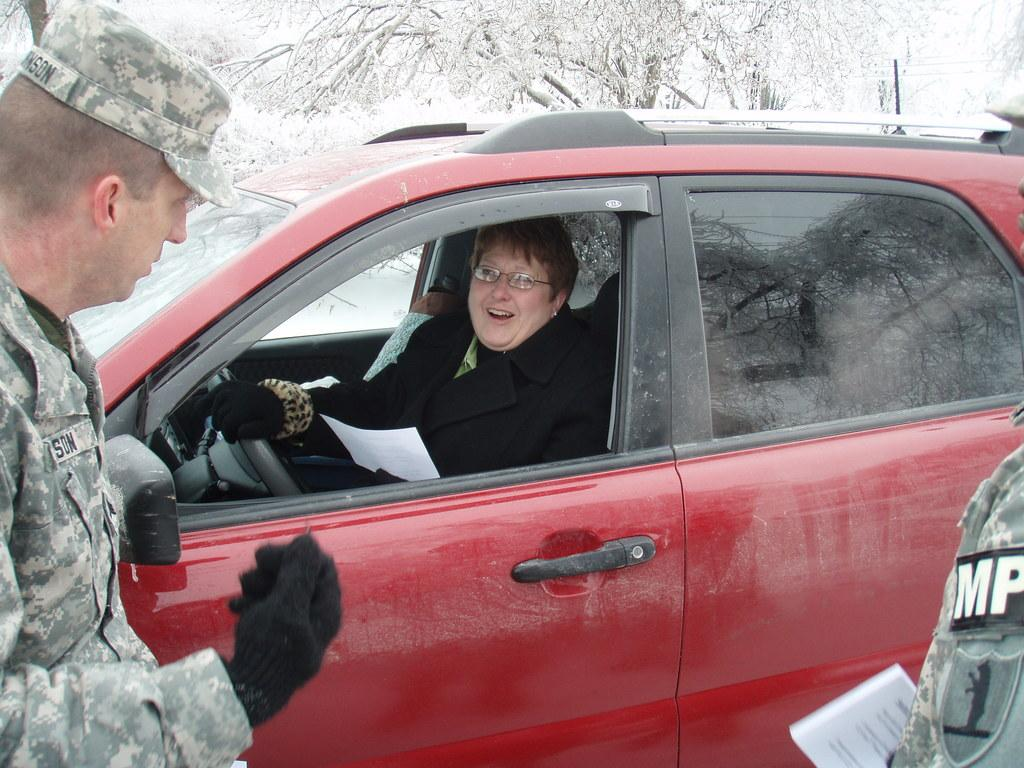How many people are present in the image? There are two people standing in the image. What is the third person in the image doing? The person inside the car is sitting and holding a paper. What can be seen in the background of the image? There are trees in the background of the image. What is the condition of the trees in the image? The trees are covered with snow. What language is the person inside the car speaking in the image? There is no information about the language being spoken in the image. How many geese are visible in the image? There are no geese present in the image. 